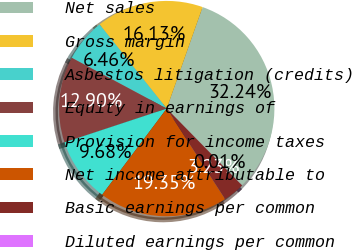Convert chart. <chart><loc_0><loc_0><loc_500><loc_500><pie_chart><fcel>Net sales<fcel>Gross margin<fcel>Asbestos litigation (credits)<fcel>Equity in earnings of<fcel>Provision for income taxes<fcel>Net income attributable to<fcel>Basic earnings per common<fcel>Diluted earnings per common<nl><fcel>32.24%<fcel>16.13%<fcel>6.46%<fcel>12.9%<fcel>9.68%<fcel>19.35%<fcel>3.23%<fcel>0.01%<nl></chart> 